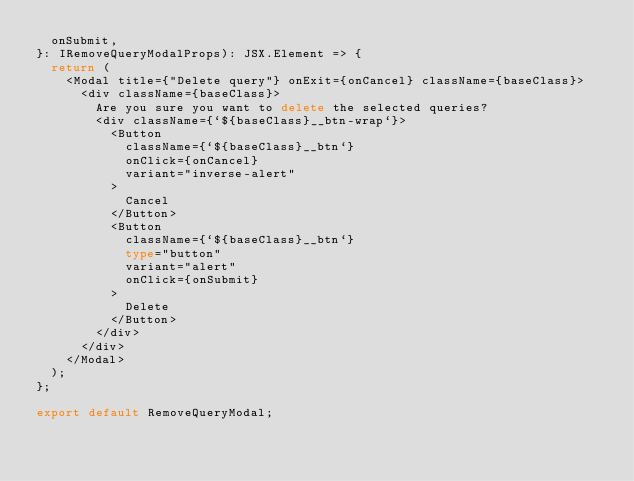<code> <loc_0><loc_0><loc_500><loc_500><_TypeScript_>  onSubmit,
}: IRemoveQueryModalProps): JSX.Element => {
  return (
    <Modal title={"Delete query"} onExit={onCancel} className={baseClass}>
      <div className={baseClass}>
        Are you sure you want to delete the selected queries?
        <div className={`${baseClass}__btn-wrap`}>
          <Button
            className={`${baseClass}__btn`}
            onClick={onCancel}
            variant="inverse-alert"
          >
            Cancel
          </Button>
          <Button
            className={`${baseClass}__btn`}
            type="button"
            variant="alert"
            onClick={onSubmit}
          >
            Delete
          </Button>
        </div>
      </div>
    </Modal>
  );
};

export default RemoveQueryModal;
</code> 